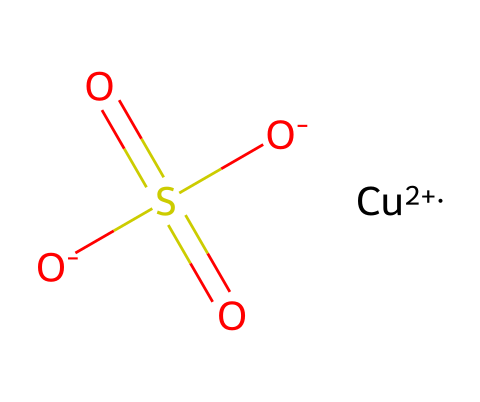What is the molecular formula of copper sulfate? The SMILES representation shows one copper (Cu), one sulfur (S), and four oxygen (O) atoms is present. This can be combined to form the molecular formula CuSO4.
Answer: CuSO4 How many atoms are in copper sulfate? By counting the individual elements from the molecular formula, there are 1 copper atom, 1 sulfur atom, and 4 oxygen atoms, resulting in a total of 6 atoms.
Answer: 6 What is the charge on the copper ion in copper sulfate? The notation in the SMILES indicates that copper is present as Cu+2, which signifies it has a +2 charge.
Answer: +2 What is the oxidation state of sulfur in copper sulfate? In the sulfate ion (SO4), sulfur typically has an oxidation state of +6, determined by counting the oxygen atoms' contributions (each O is -2, and there are 4 O’s).
Answer: +6 What type of compound is copper sulfate classified as? Copper sulfate is classified as an inorganic salt, as it is formed from the reaction of a metal (copper) and a non-metal (sulfur and oxygen).
Answer: inorganic salt How does the presence of copper sulfate help in preserving stage props? Copper sulfate functions as a fungicide, inhibiting the growth of fungi, which helps preserve organic materials in stage props from decay or mold.
Answer: fungicide What characteristic of copper sulfate contributes to its fungicidal properties? The ability of copper ions to disrupt fungal cell membranes and interfere with metabolic processes contributes to its fungicidal effect.
Answer: copper ions 